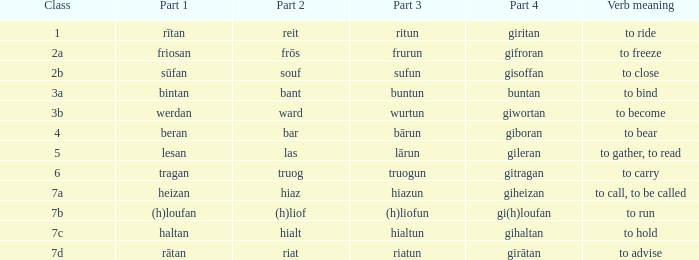What group in the expression with portion 4 "giheizan"? 7a. 